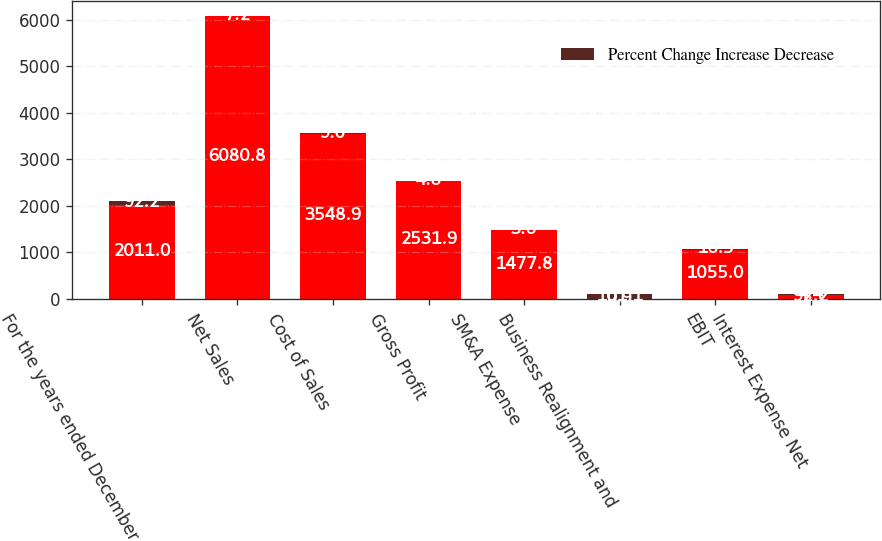Convert chart to OTSL. <chart><loc_0><loc_0><loc_500><loc_500><stacked_bar_chart><ecel><fcel>For the years ended December<fcel>Net Sales<fcel>Cost of Sales<fcel>Gross Profit<fcel>SM&A Expense<fcel>Business Realignment and<fcel>EBIT<fcel>Interest Expense Net<nl><fcel>nan<fcel>2011<fcel>6080.8<fcel>3548.9<fcel>2531.9<fcel>1477.8<fcel>0.9<fcel>1055<fcel>92.2<nl><fcel>Percent Change Increase Decrease<fcel>92.2<fcel>7.2<fcel>9<fcel>4.8<fcel>3.6<fcel>101.1<fcel>16.5<fcel>4.4<nl></chart> 